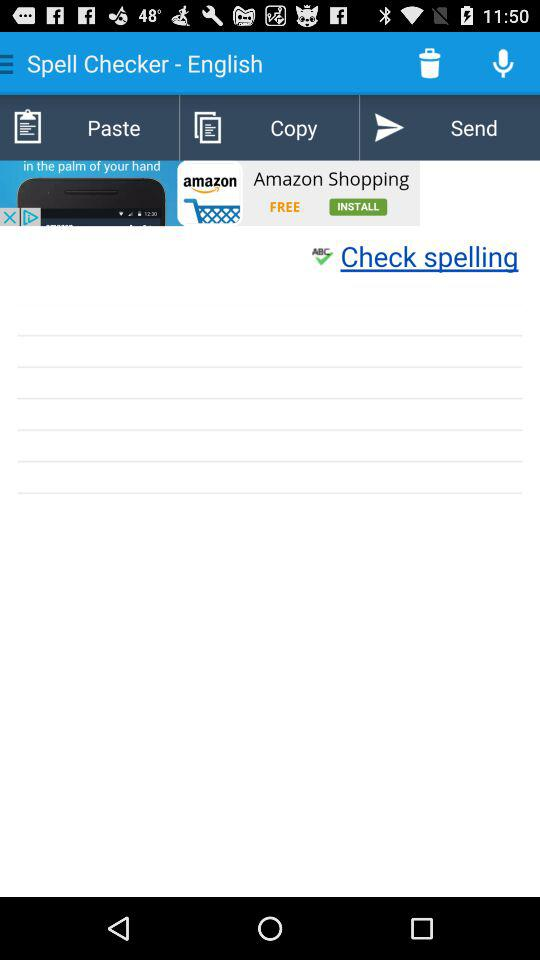What’s the app name? The app name is "Spell Checker - English". 